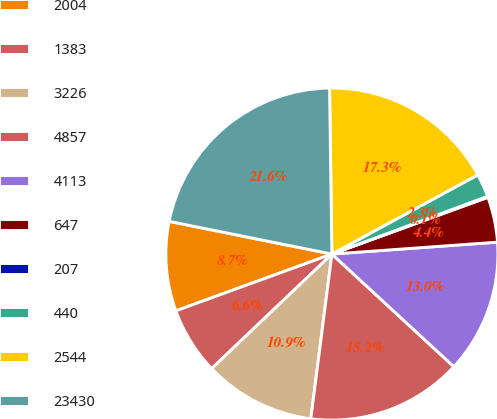<chart> <loc_0><loc_0><loc_500><loc_500><pie_chart><fcel>2004<fcel>1383<fcel>3226<fcel>4857<fcel>4113<fcel>647<fcel>207<fcel>440<fcel>2544<fcel>23430<nl><fcel>8.71%<fcel>6.56%<fcel>10.86%<fcel>15.16%<fcel>13.01%<fcel>4.41%<fcel>0.1%<fcel>2.26%<fcel>17.31%<fcel>21.62%<nl></chart> 